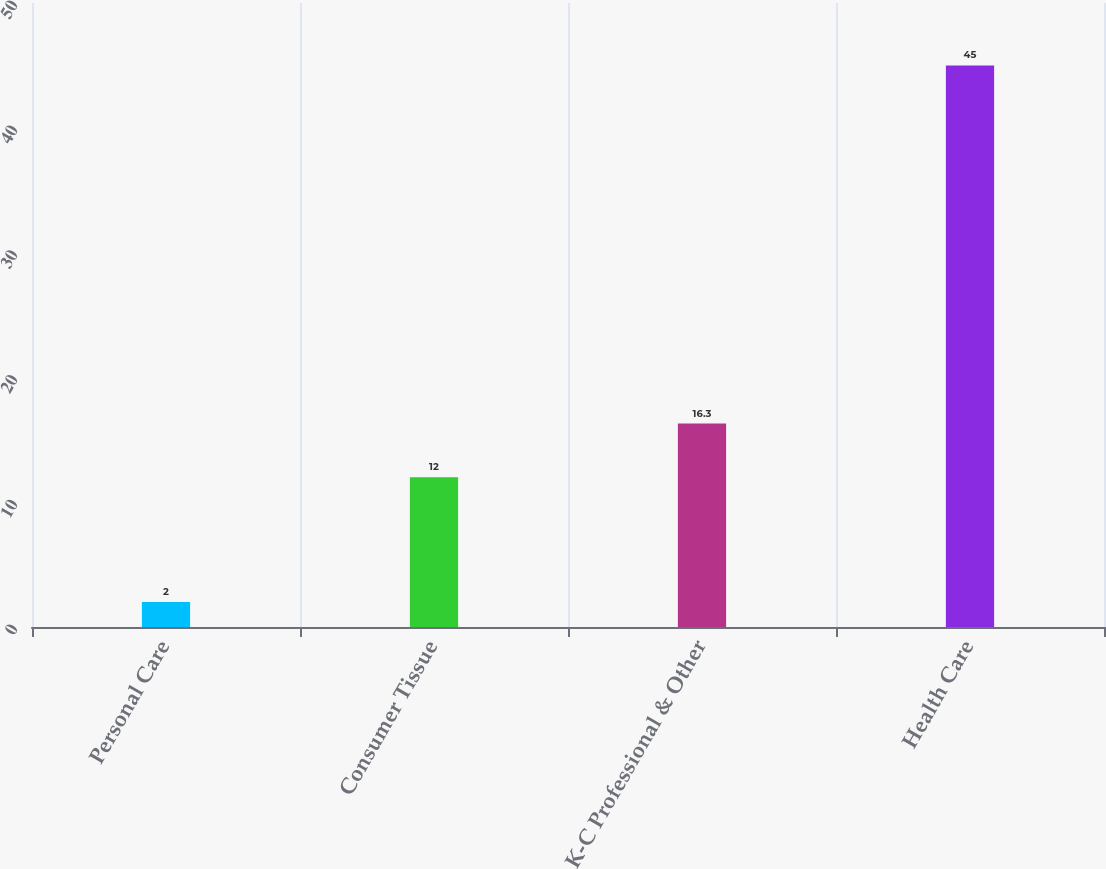Convert chart to OTSL. <chart><loc_0><loc_0><loc_500><loc_500><bar_chart><fcel>Personal Care<fcel>Consumer Tissue<fcel>K-C Professional & Other<fcel>Health Care<nl><fcel>2<fcel>12<fcel>16.3<fcel>45<nl></chart> 